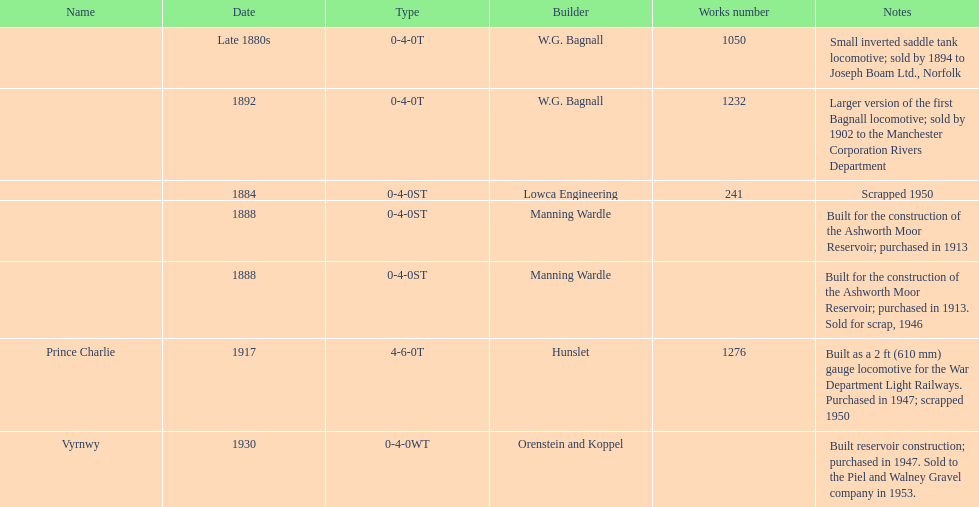How many locomotives were built after 1900? 2. 